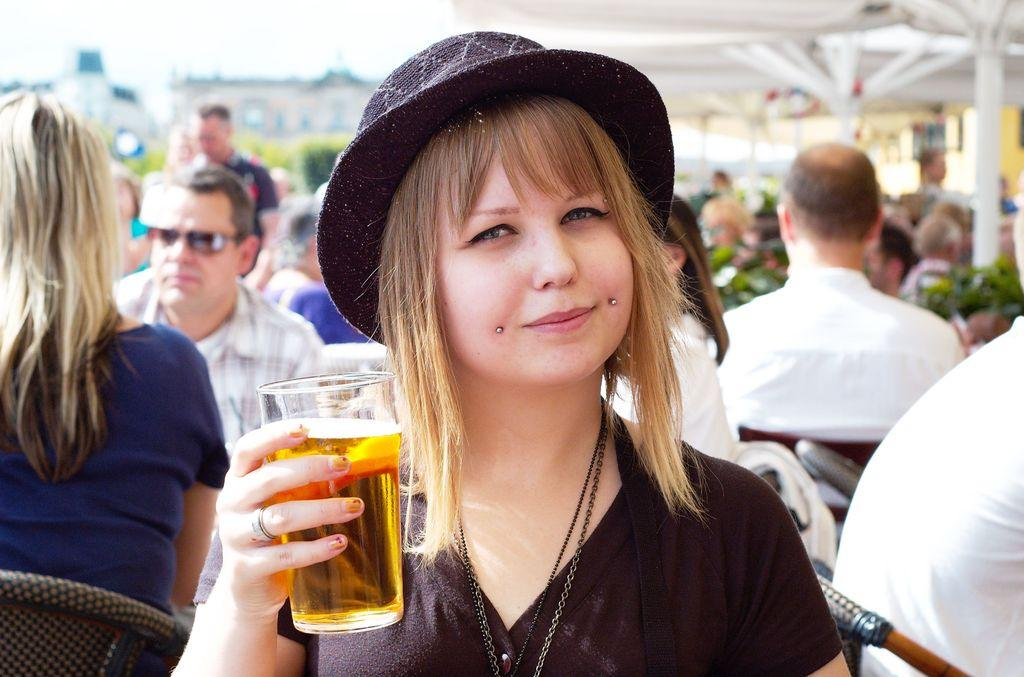Who is the main subject in the image? There is a woman in the image. What is the woman holding in her hands? The woman is holding a glass with a drink in her hands. Can you describe the setting of the image? There are many people in the background of the image. What type of bee can be seen flying around the woman's head in the image? There is no bee present in the image. What color is the curtain behind the woman in the image? There is no curtain visible in the image. 